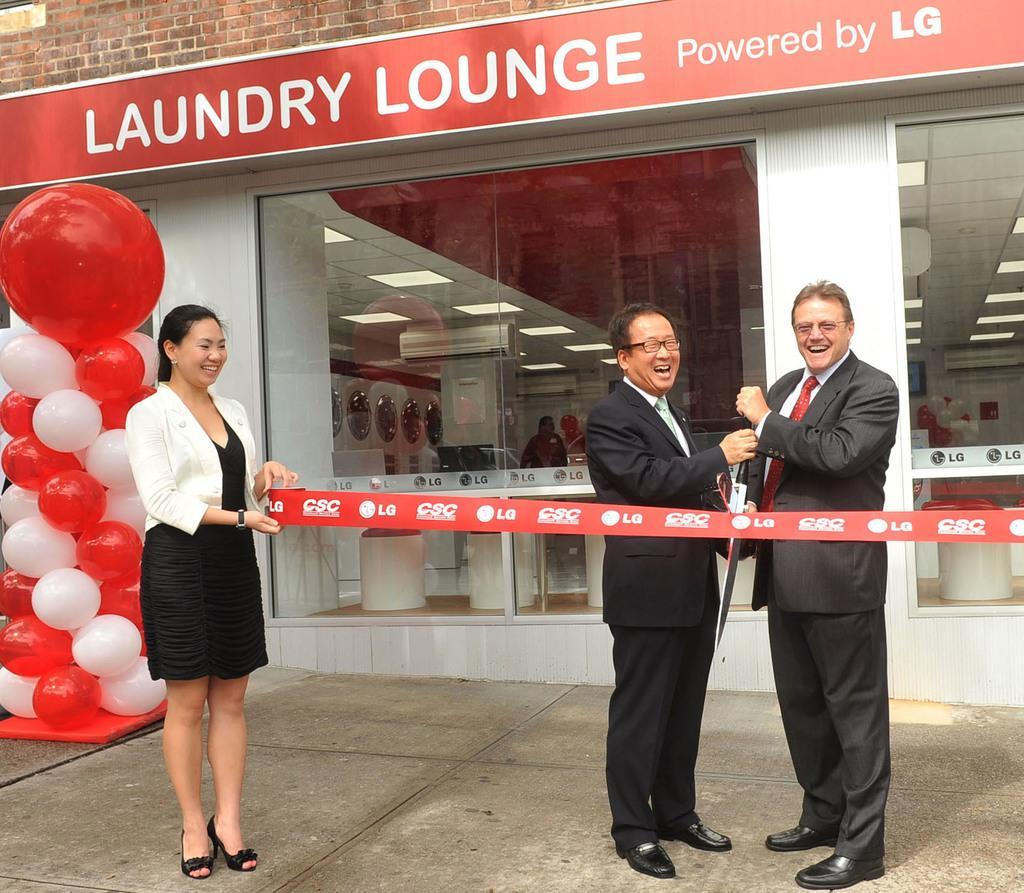Please provide a concise description of this image. In this image I can see a woman and two men are standing in the front. I can see all of them are smiling and all of them are wearing formal dress. I can also see she is holding a red colour thing and on it I can see something is written. On the left side of the image I can see number of balloons. In the background I can see a store, a red colour board and number of lights on the ceiling. I can also see something is written on the board. I can also see number of stuffs and few people in the background. 